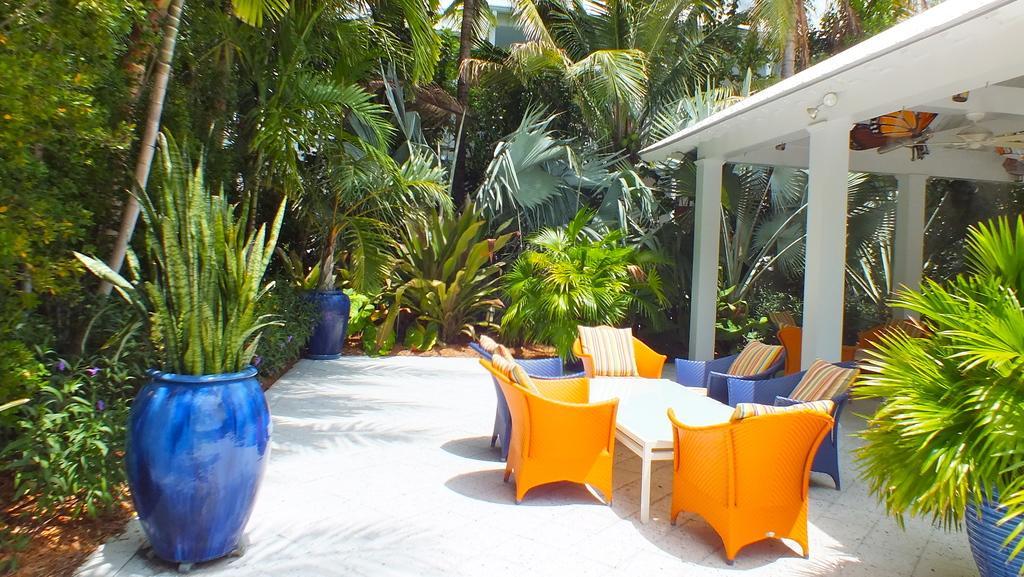Describe this image in one or two sentences. This image is taken in a garden. There are many trees and plants in this image. In the left side of the image there is a plant in a pot. In the bottom of the image there is a floor. In the middle of the image there are few empty chairs with pillows on them and there is a table. In the right side of the image there is a roof with pillars and a ceiling fan. 